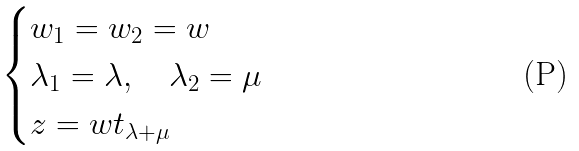Convert formula to latex. <formula><loc_0><loc_0><loc_500><loc_500>\begin{cases} w _ { 1 } = w _ { 2 } = w \\ \lambda _ { 1 } = \lambda , \quad \lambda _ { 2 } = \mu \\ z = w t _ { \lambda + \mu } \end{cases}</formula> 